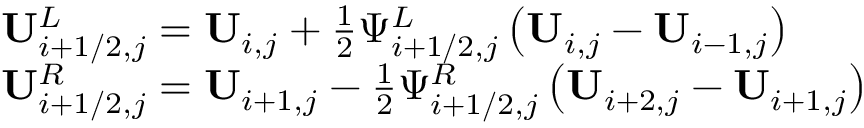Convert formula to latex. <formula><loc_0><loc_0><loc_500><loc_500>\begin{array} { r l } & { U _ { i + 1 / 2 , j } ^ { L } = U _ { i , j } + \frac { 1 } { 2 } \Psi _ { i + 1 / 2 , j } ^ { L } \left ( U _ { i , j } - U _ { i - 1 , j } \right ) } \\ & { U _ { i + 1 / 2 , j } ^ { R } = U _ { i + 1 , j } - \frac { 1 } { 2 } \Psi _ { i + 1 / 2 , j } ^ { R } \left ( U _ { i + 2 , j } - U _ { i + 1 , j } \right ) } \end{array}</formula> 